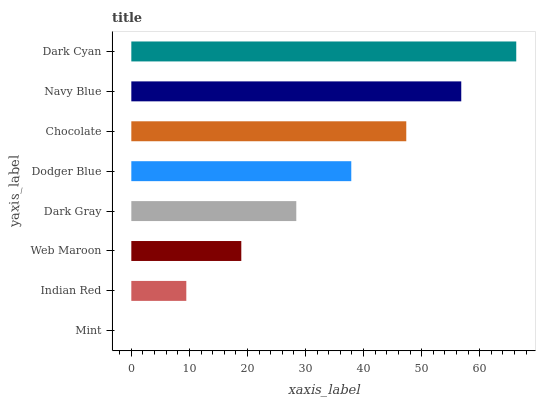Is Mint the minimum?
Answer yes or no. Yes. Is Dark Cyan the maximum?
Answer yes or no. Yes. Is Indian Red the minimum?
Answer yes or no. No. Is Indian Red the maximum?
Answer yes or no. No. Is Indian Red greater than Mint?
Answer yes or no. Yes. Is Mint less than Indian Red?
Answer yes or no. Yes. Is Mint greater than Indian Red?
Answer yes or no. No. Is Indian Red less than Mint?
Answer yes or no. No. Is Dodger Blue the high median?
Answer yes or no. Yes. Is Dark Gray the low median?
Answer yes or no. Yes. Is Chocolate the high median?
Answer yes or no. No. Is Chocolate the low median?
Answer yes or no. No. 